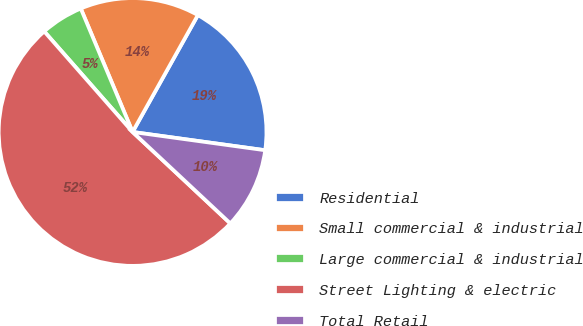Convert chart. <chart><loc_0><loc_0><loc_500><loc_500><pie_chart><fcel>Residential<fcel>Small commercial & industrial<fcel>Large commercial & industrial<fcel>Street Lighting & electric<fcel>Total Retail<nl><fcel>19.07%<fcel>14.43%<fcel>5.15%<fcel>51.55%<fcel>9.79%<nl></chart> 